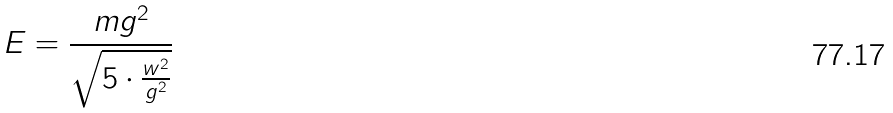<formula> <loc_0><loc_0><loc_500><loc_500>E = \frac { m g ^ { 2 } } { \sqrt { 5 \cdot \frac { w ^ { 2 } } { g ^ { 2 } } } }</formula> 